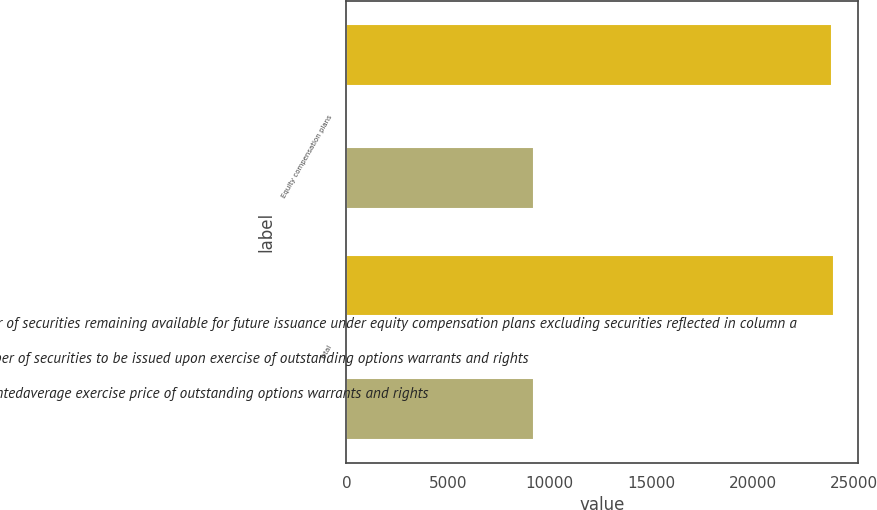Convert chart. <chart><loc_0><loc_0><loc_500><loc_500><stacked_bar_chart><ecel><fcel>Equity compensation plans<fcel>Total<nl><fcel>Number of securities remaining available for future issuance under equity compensation plans excluding securities reflected in column a<fcel>23926<fcel>23996<nl><fcel>a Number of securities to be issued upon exercise of outstanding options warrants and rights<fcel>59.93<fcel>59.93<nl><fcel>b Weightedaverage exercise price of outstanding options warrants and rights<fcel>9244<fcel>9244<nl></chart> 